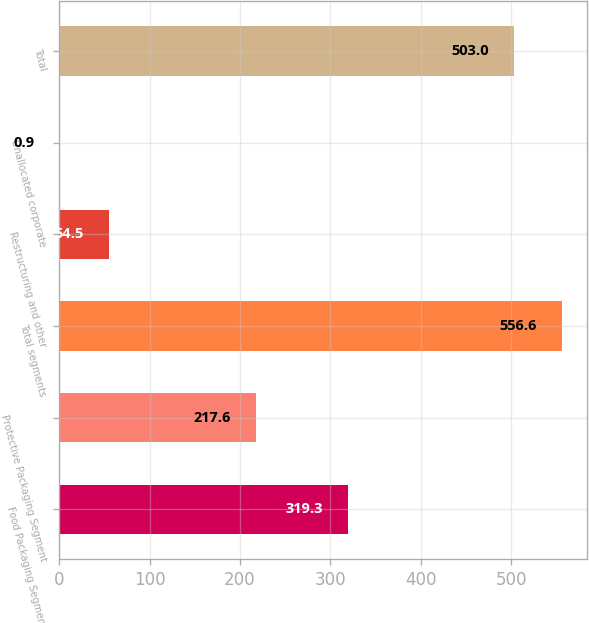<chart> <loc_0><loc_0><loc_500><loc_500><bar_chart><fcel>Food Packaging Segment<fcel>Protective Packaging Segment<fcel>Total segments<fcel>Restructuring and other<fcel>Unallocated corporate<fcel>Total<nl><fcel>319.3<fcel>217.6<fcel>556.6<fcel>54.5<fcel>0.9<fcel>503<nl></chart> 